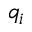<formula> <loc_0><loc_0><loc_500><loc_500>q _ { i }</formula> 